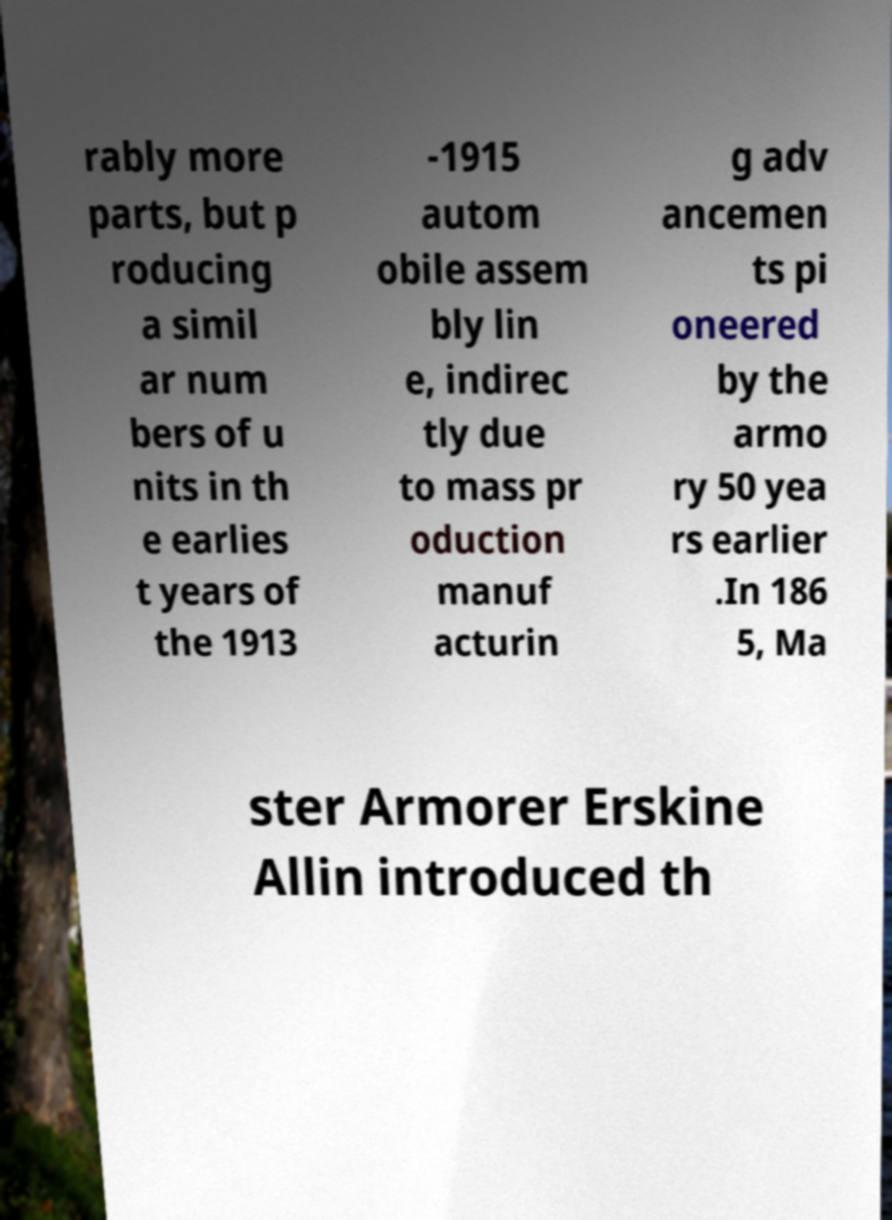Please read and relay the text visible in this image. What does it say? rably more parts, but p roducing a simil ar num bers of u nits in th e earlies t years of the 1913 -1915 autom obile assem bly lin e, indirec tly due to mass pr oduction manuf acturin g adv ancemen ts pi oneered by the armo ry 50 yea rs earlier .In 186 5, Ma ster Armorer Erskine Allin introduced th 